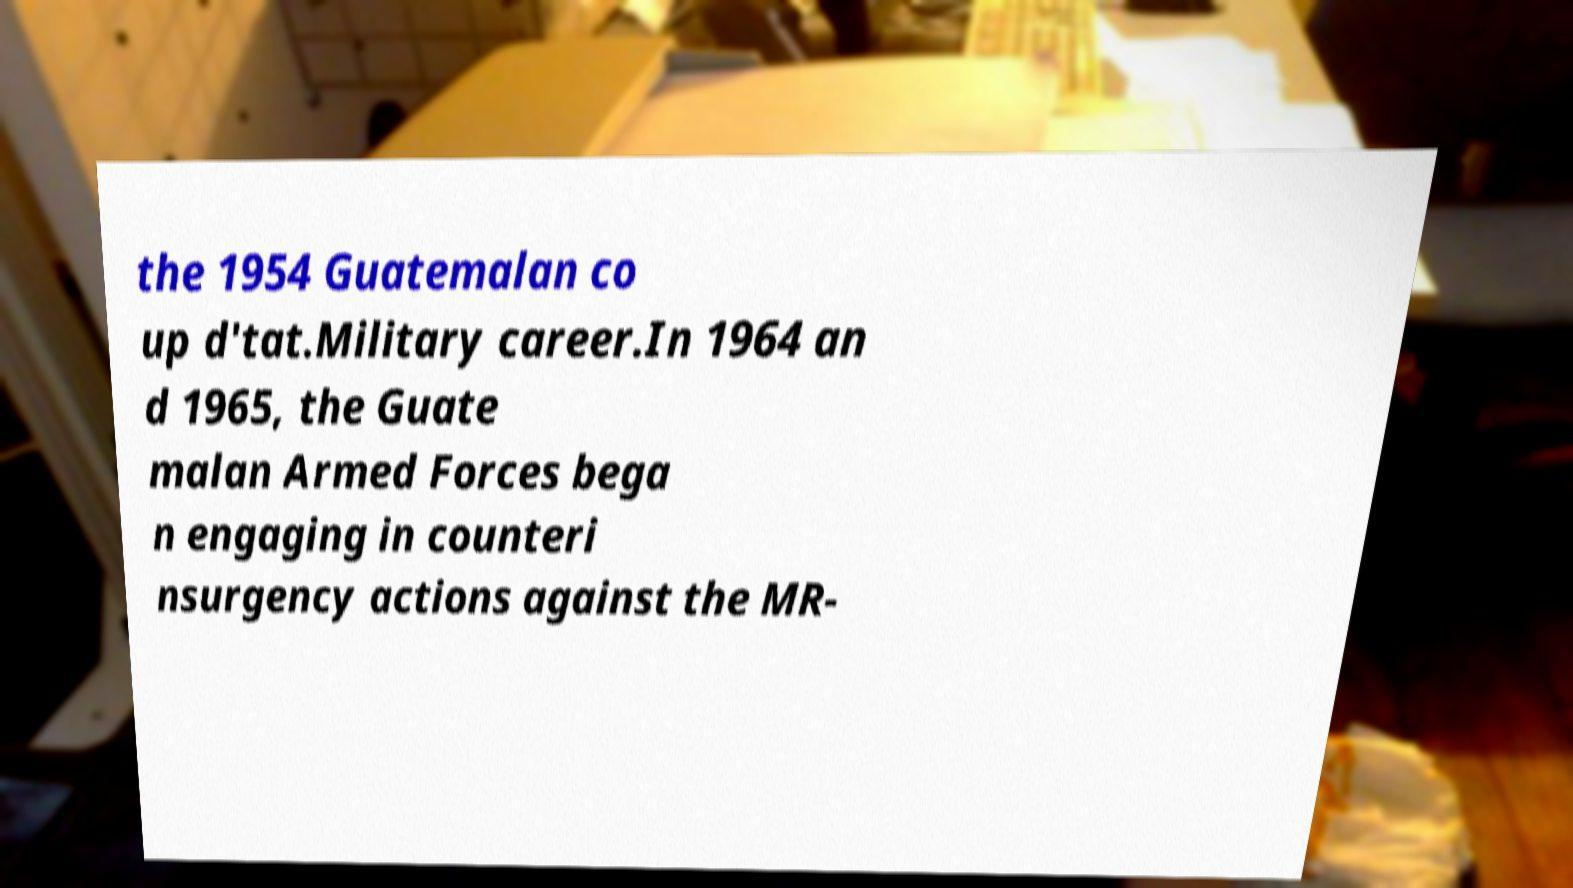What messages or text are displayed in this image? I need them in a readable, typed format. the 1954 Guatemalan co up d'tat.Military career.In 1964 an d 1965, the Guate malan Armed Forces bega n engaging in counteri nsurgency actions against the MR- 